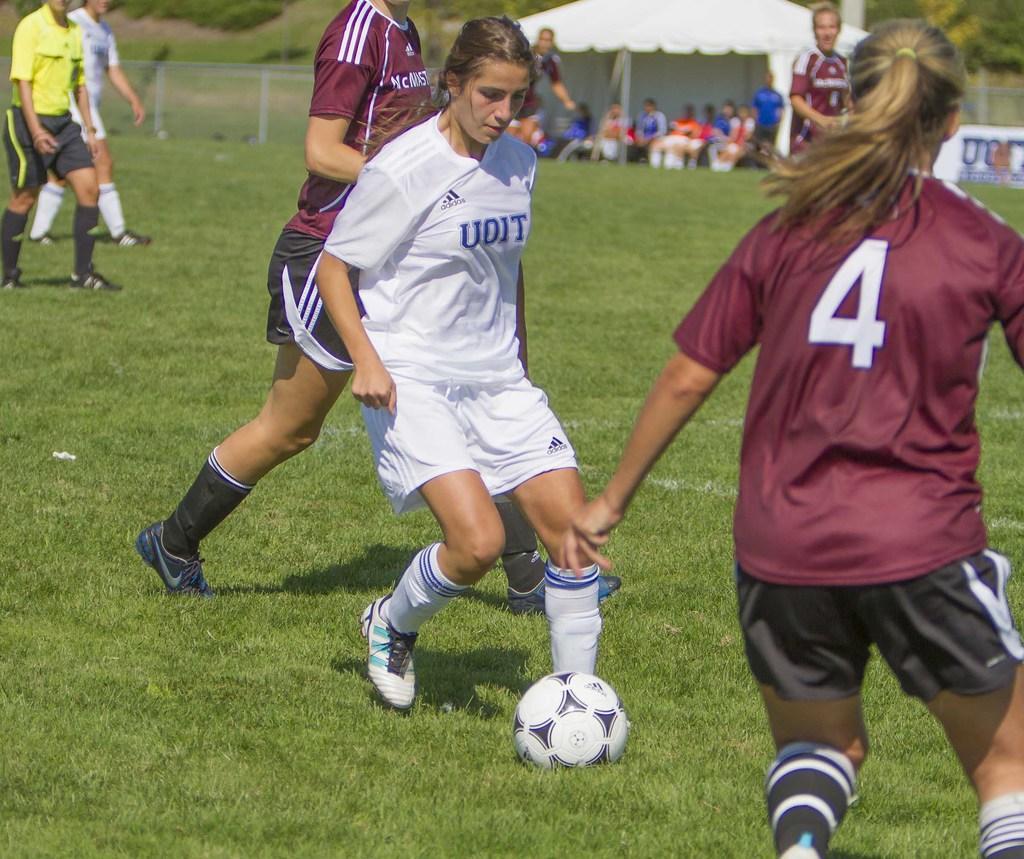Describe this image in one or two sentences. This image consists of two women playing football. In the background, there are many people. At the bottom, there is green grass on the ground. In the middle, there is a ball. And we can see a tent in white color along with fencing. At the top, there is sky. 